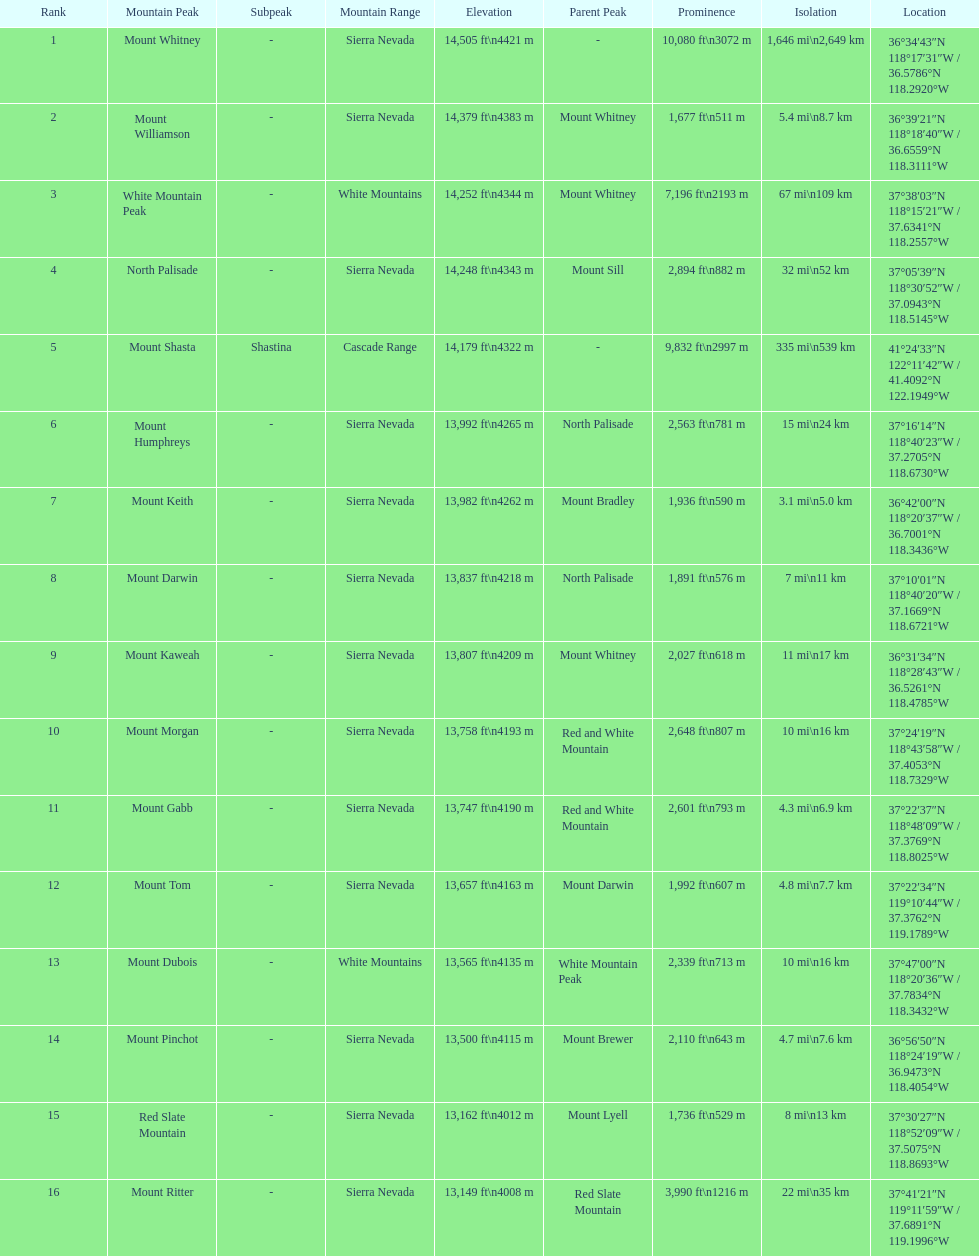What is the total elevation (in ft) of mount whitney? 14,505 ft. 